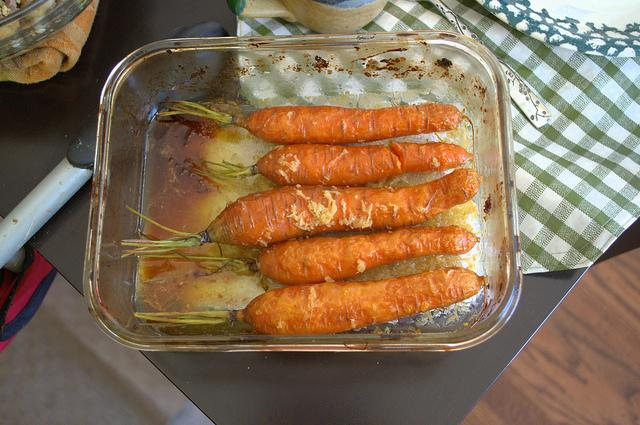Where did the food in the dish come from? ground 